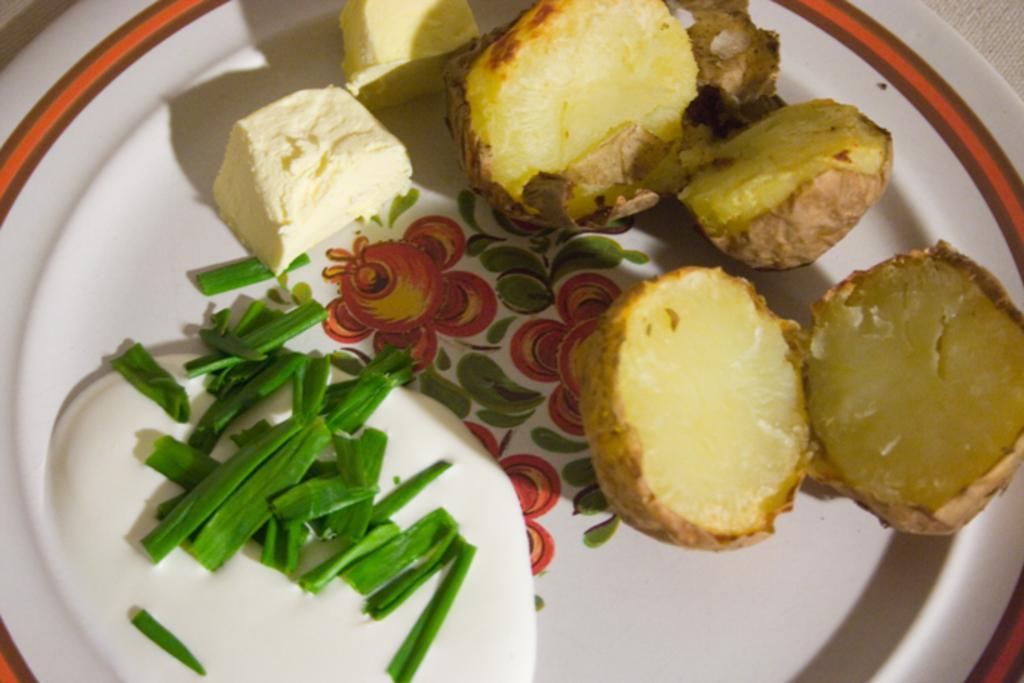Can you describe this image briefly? In this image on a plate there are baked potatoes,butter, spring onion, sauce is there. 